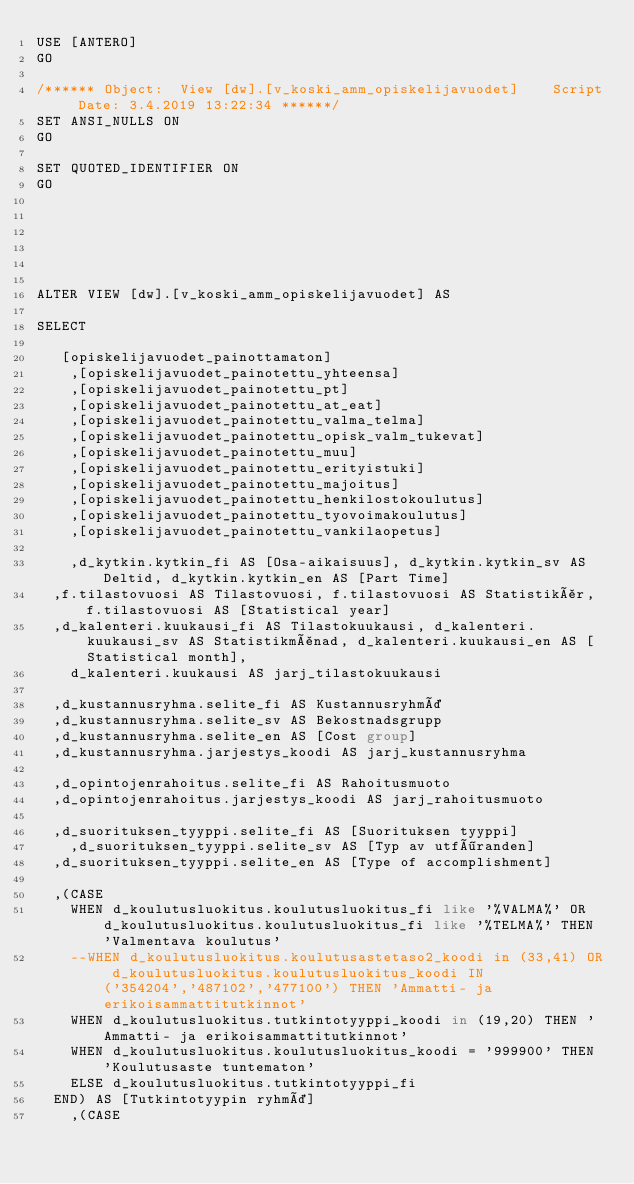<code> <loc_0><loc_0><loc_500><loc_500><_SQL_>USE [ANTERO]
GO

/****** Object:  View [dw].[v_koski_amm_opiskelijavuodet]    Script Date: 3.4.2019 13:22:34 ******/
SET ANSI_NULLS ON
GO

SET QUOTED_IDENTIFIER ON
GO






ALTER VIEW [dw].[v_koski_amm_opiskelijavuodet] AS

SELECT        

	 [opiskelijavuodet_painottamaton]
    ,[opiskelijavuodet_painotettu_yhteensa]
    ,[opiskelijavuodet_painotettu_pt]
    ,[opiskelijavuodet_painotettu_at_eat]
    ,[opiskelijavuodet_painotettu_valma_telma]
    ,[opiskelijavuodet_painotettu_opisk_valm_tukevat]
    ,[opiskelijavuodet_painotettu_muu]
    ,[opiskelijavuodet_painotettu_erityistuki]
    ,[opiskelijavuodet_painotettu_majoitus]
    ,[opiskelijavuodet_painotettu_henkilostokoulutus]
    ,[opiskelijavuodet_painotettu_tyovoimakoulutus]
    ,[opiskelijavuodet_painotettu_vankilaopetus]

    ,d_kytkin.kytkin_fi AS [Osa-aikaisuus], d_kytkin.kytkin_sv AS Deltid, d_kytkin.kytkin_en AS [Part Time]
	,f.tilastovuosi AS Tilastovuosi, f.tilastovuosi AS Statistikår, f.tilastovuosi AS [Statistical year]
	,d_kalenteri.kuukausi_fi AS Tilastokuukausi, d_kalenteri.kuukausi_sv AS Statistikmånad, d_kalenteri.kuukausi_en AS [Statistical month], 
    d_kalenteri.kuukausi AS jarj_tilastokuukausi

	,d_kustannusryhma.selite_fi AS Kustannusryhmä
	,d_kustannusryhma.selite_sv AS Bekostnadsgrupp
	,d_kustannusryhma.selite_en AS [Cost group]
	,d_kustannusryhma.jarjestys_koodi AS jarj_kustannusryhma

	,d_opintojenrahoitus.selite_fi AS Rahoitusmuoto
	,d_opintojenrahoitus.jarjestys_koodi AS jarj_rahoitusmuoto

	,d_suorituksen_tyyppi.selite_fi AS [Suorituksen tyyppi]
    ,d_suorituksen_tyyppi.selite_sv AS [Typ av utföranden]
	,d_suorituksen_tyyppi.selite_en AS [Type of accomplishment]

	,(CASE 
		WHEN d_koulutusluokitus.koulutusluokitus_fi like '%VALMA%' OR d_koulutusluokitus.koulutusluokitus_fi like '%TELMA%' THEN 'Valmentava koulutus' 
		--WHEN d_koulutusluokitus.koulutusastetaso2_koodi in (33,41) OR d_koulutusluokitus.koulutusluokitus_koodi IN ('354204','487102','477100') THEN 'Ammatti- ja erikoisammattitutkinnot' 
		WHEN d_koulutusluokitus.tutkintotyyppi_koodi in (19,20) THEN 'Ammatti- ja erikoisammattitutkinnot' 
		WHEN d_koulutusluokitus.koulutusluokitus_koodi = '999900' THEN 'Koulutusaste tuntematon'
		ELSE d_koulutusluokitus.tutkintotyyppi_fi
	END) AS [Tutkintotyypin ryhmä]
    ,(CASE </code> 